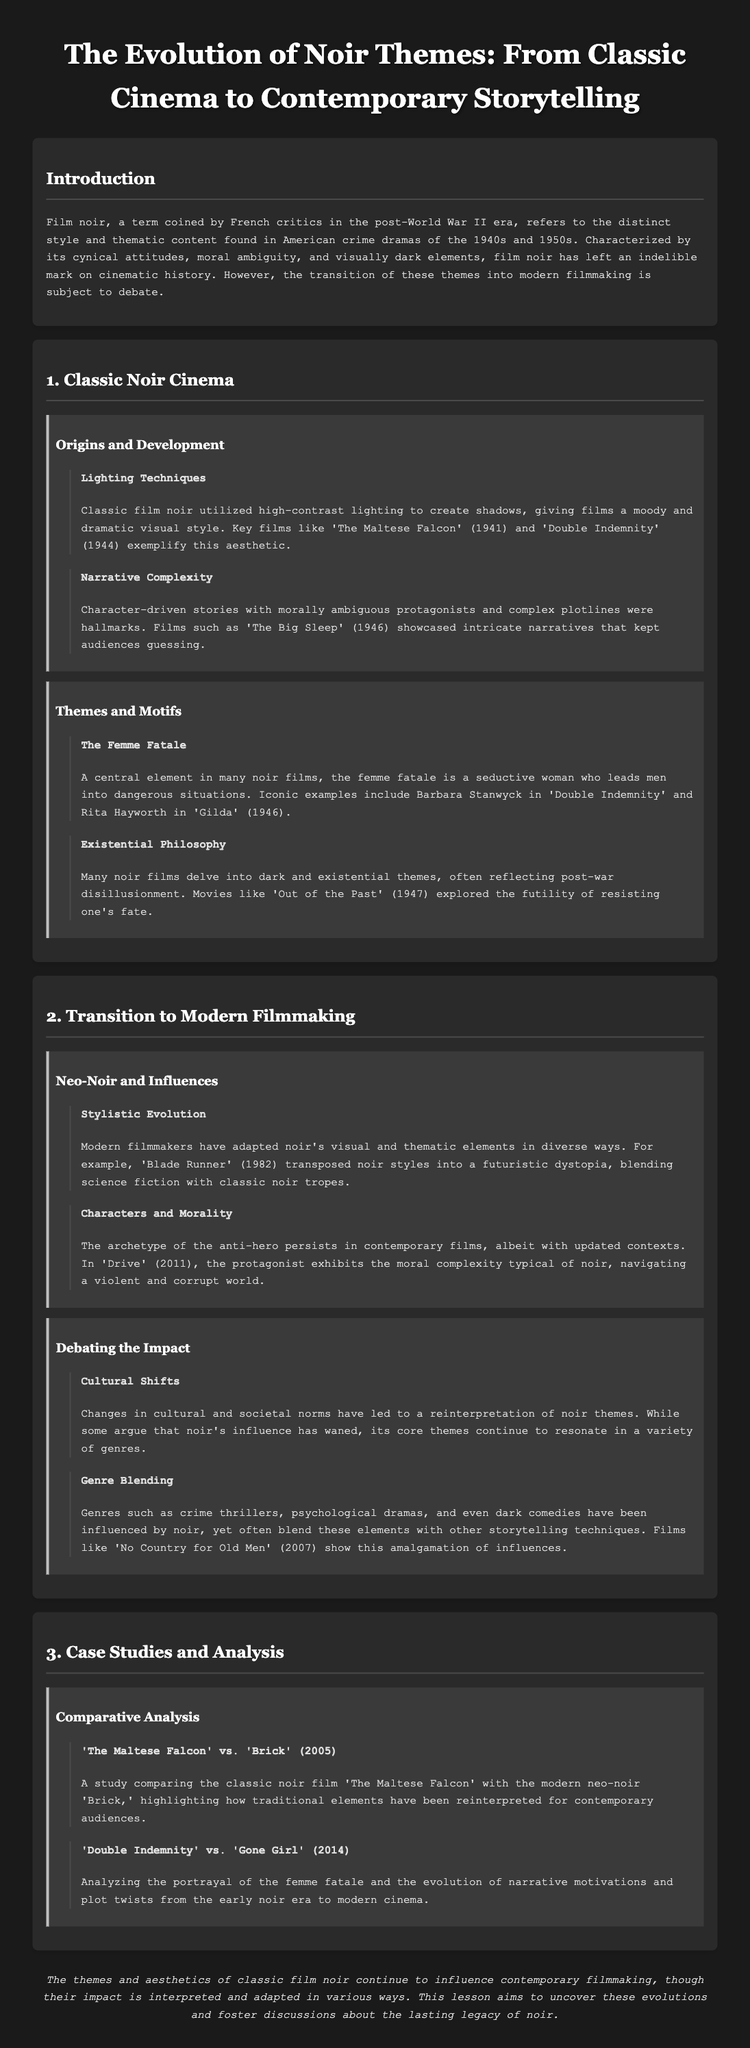What is the term coined by French critics to describe a genre of American crime dramas? The document states that "film noir" was a term coined by French critics.
Answer: film noir Which two classic films exemplify high-contrast lighting techniques? The document mentions 'The Maltese Falcon' and 'Double Indemnity' as key films exemplifying this aesthetic.
Answer: The Maltese Falcon, Double Indemnity What central character type is highlighted in many noir films? The document specifically identifies "the femme fatale" as a central element in many noir films.
Answer: the femme fatale Which modern film is mentioned as transposing noir styles into a futuristic dystopia? The document refers to 'Blade Runner' as a modern film that incorporates noir styles into a futuristic setting.
Answer: Blade Runner What argument is made about noir's influence on contemporary genres? The document states that some argue that noir's influence has waned, but its core themes still resonate.
Answer: influence has waned How many films are compared in the case studies section? The document lists two pairings of films for comparative analysis in the case studies section.
Answer: two What existential theme is explored in many classic noir films? The document mentions that many noir films delve into "dark and existential themes," often reflecting post-war disillusionment.
Answer: existential themes Who starred as the femme fatale in 'Double Indemnity'? The document mentions Barbara Stanwyck as an iconic example of the femme fatale in 'Double Indemnity'.
Answer: Barbara Stanwyck In what year did 'Gilda' release? The document states that 'Gilda' was released in 1946.
Answer: 1946 